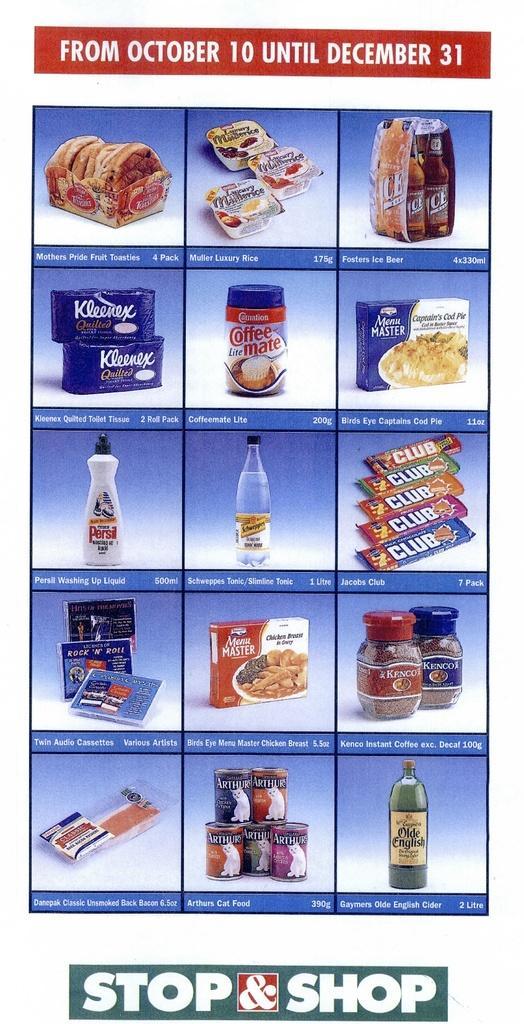Could you give a brief overview of what you see in this image? There is a poster in the image, where we can see text and images on it. 